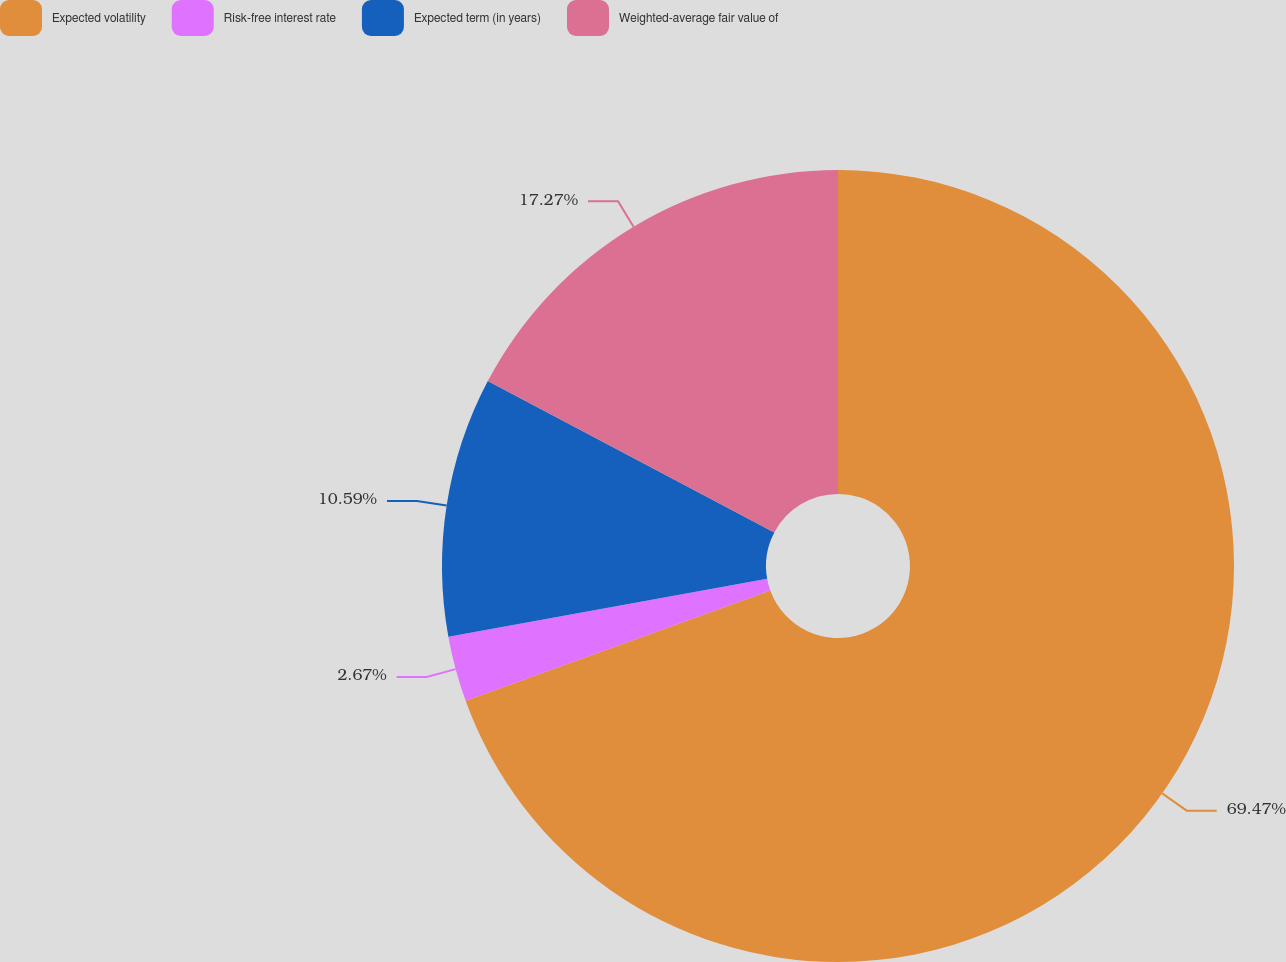Convert chart. <chart><loc_0><loc_0><loc_500><loc_500><pie_chart><fcel>Expected volatility<fcel>Risk-free interest rate<fcel>Expected term (in years)<fcel>Weighted-average fair value of<nl><fcel>69.48%<fcel>2.67%<fcel>10.59%<fcel>17.27%<nl></chart> 